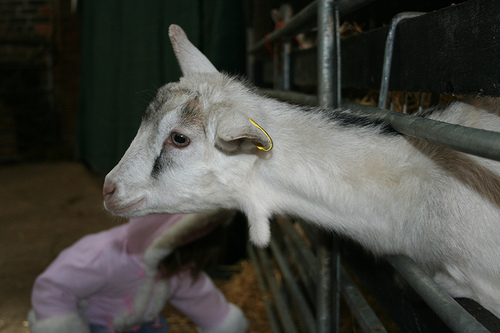<image>
Is there a goat above the jacket? Yes. The goat is positioned above the jacket in the vertical space, higher up in the scene. 